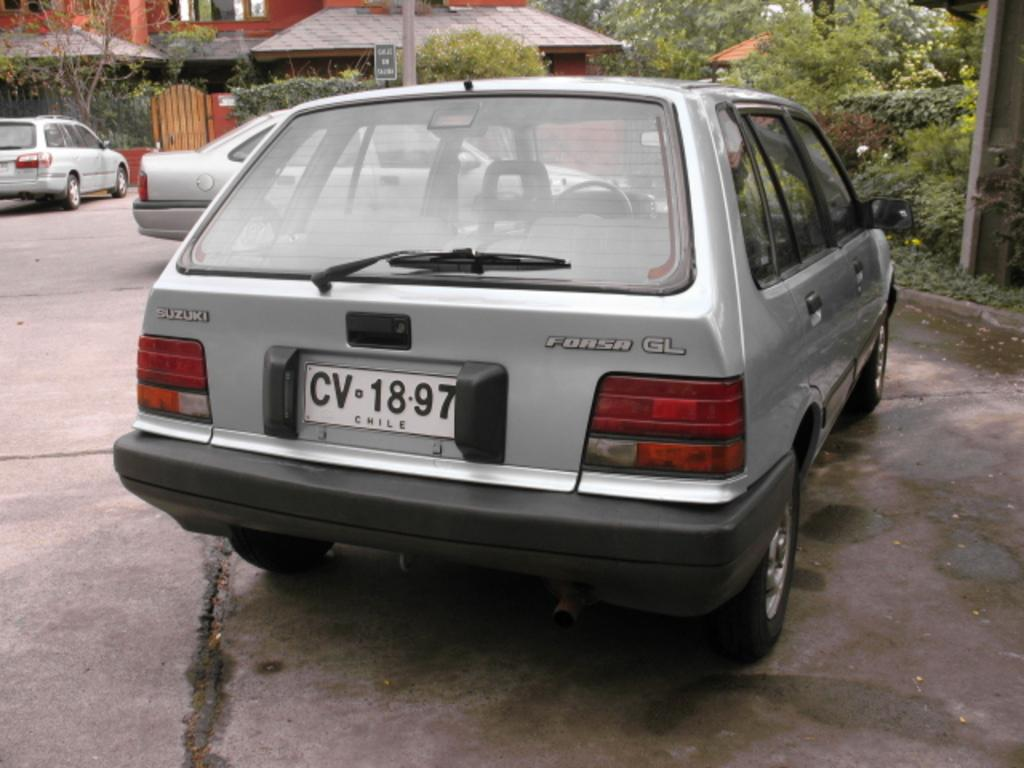<image>
Create a compact narrative representing the image presented. The car is a Suzuki Forsa GL with license plate CV-18-97 Chile 